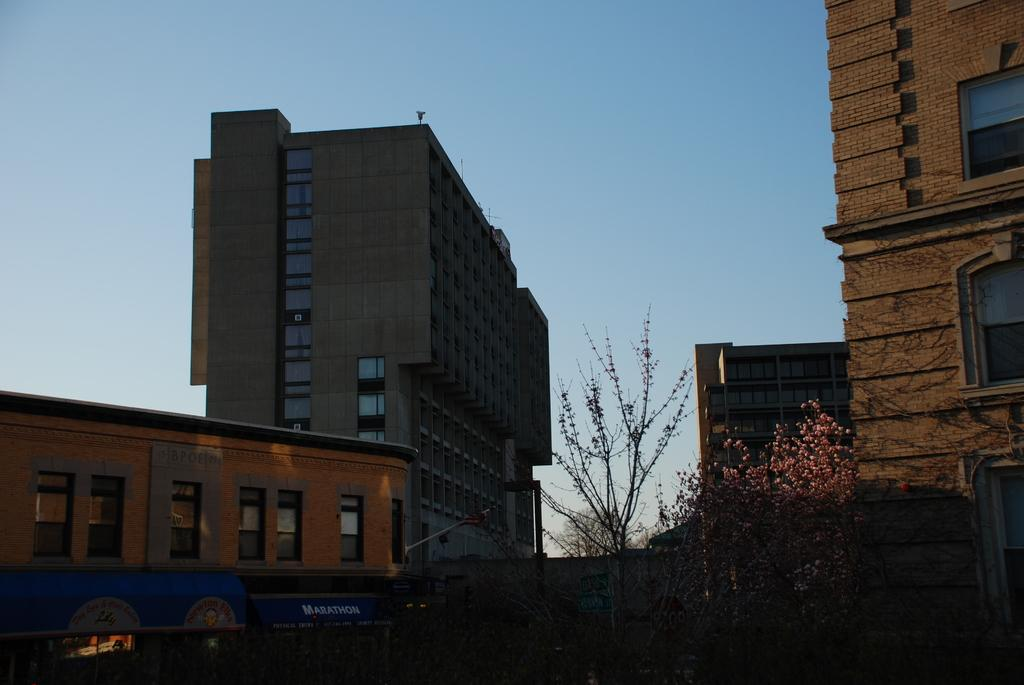What type of structures can be seen in the image? There are buildings in the image. What architectural features are visible on the buildings? There are windows visible on the buildings. What is located at the bottom of the image? At the bottom of the image, there is a wall, boards, stores, a shed, a light, and trees. What can be seen at the top of the image? At the top of the image, there is the sky. What type of breakfast is being served in the image? There is no breakfast visible in the image; it primarily features buildings, windows, and various elements at the bottom of the image. 